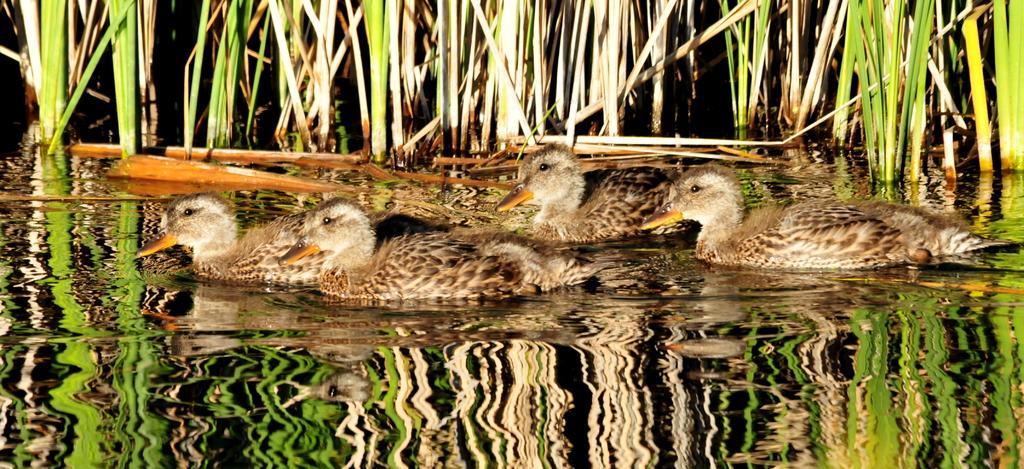Describe this image in one or two sentences. Here in this picture we can see a group of ducks present in the water over there and we can also see grass present over there. 